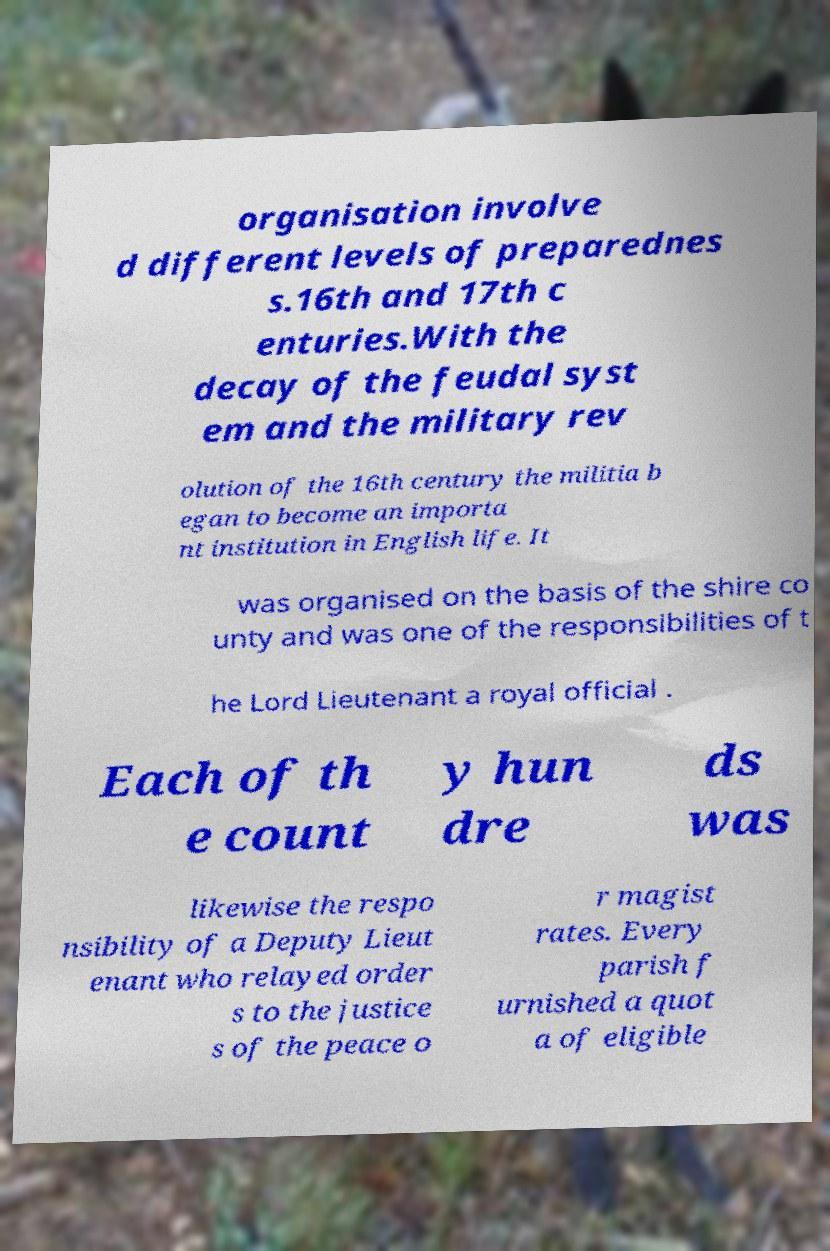There's text embedded in this image that I need extracted. Can you transcribe it verbatim? organisation involve d different levels of preparednes s.16th and 17th c enturies.With the decay of the feudal syst em and the military rev olution of the 16th century the militia b egan to become an importa nt institution in English life. It was organised on the basis of the shire co unty and was one of the responsibilities of t he Lord Lieutenant a royal official . Each of th e count y hun dre ds was likewise the respo nsibility of a Deputy Lieut enant who relayed order s to the justice s of the peace o r magist rates. Every parish f urnished a quot a of eligible 